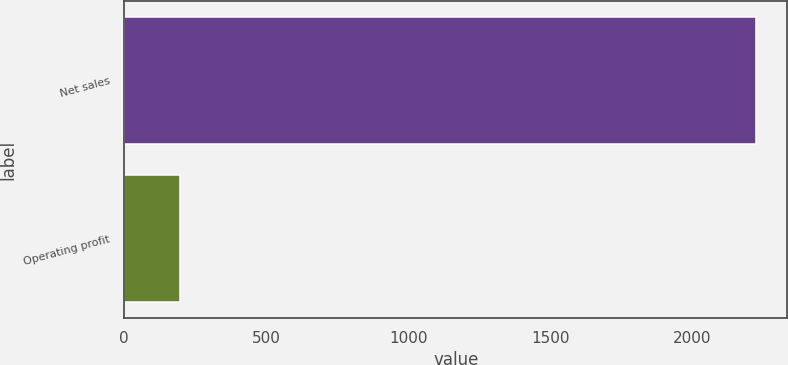Convert chart to OTSL. <chart><loc_0><loc_0><loc_500><loc_500><bar_chart><fcel>Net sales<fcel>Operating profit<nl><fcel>2222<fcel>198<nl></chart> 